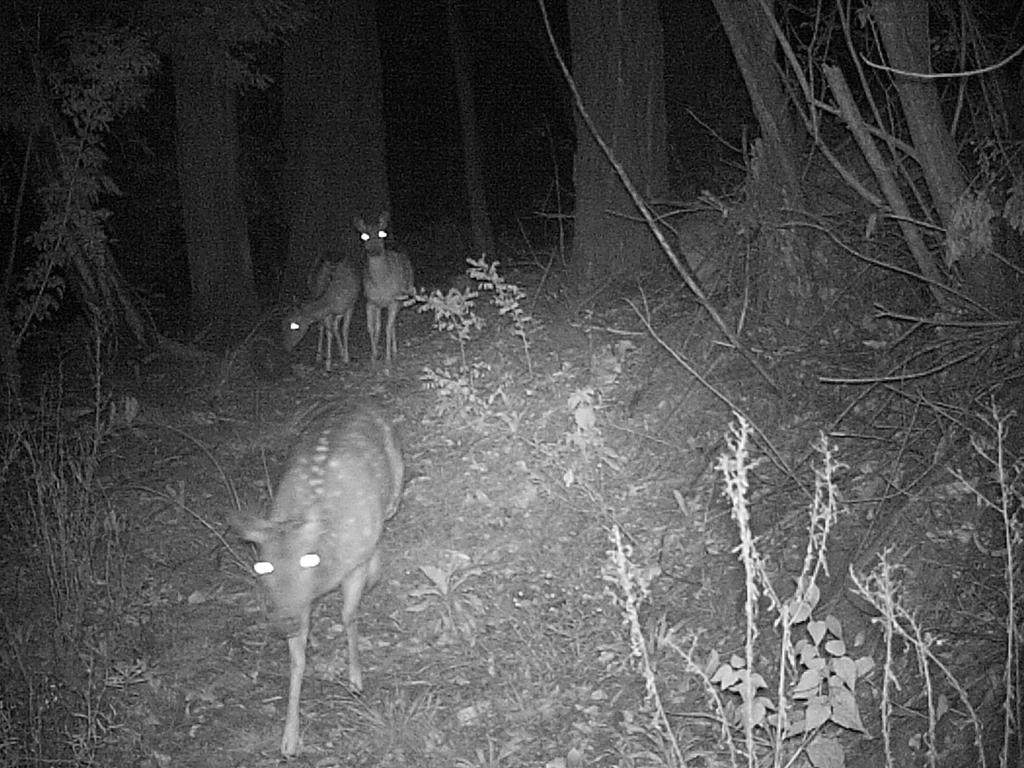How many animals can be seen in the image? There are three animals in the image. What else is present on the ground in the image besides the animals? There are plants on the ground in the image. What type of vegetation is visible in the image? There are trees in the image. What is the color of the background in the image? The background of the image is dark. Can you tell me which friend of the animals is holding a quill in the image? There is no friend of the animals present in the image, nor is there a quill visible. 